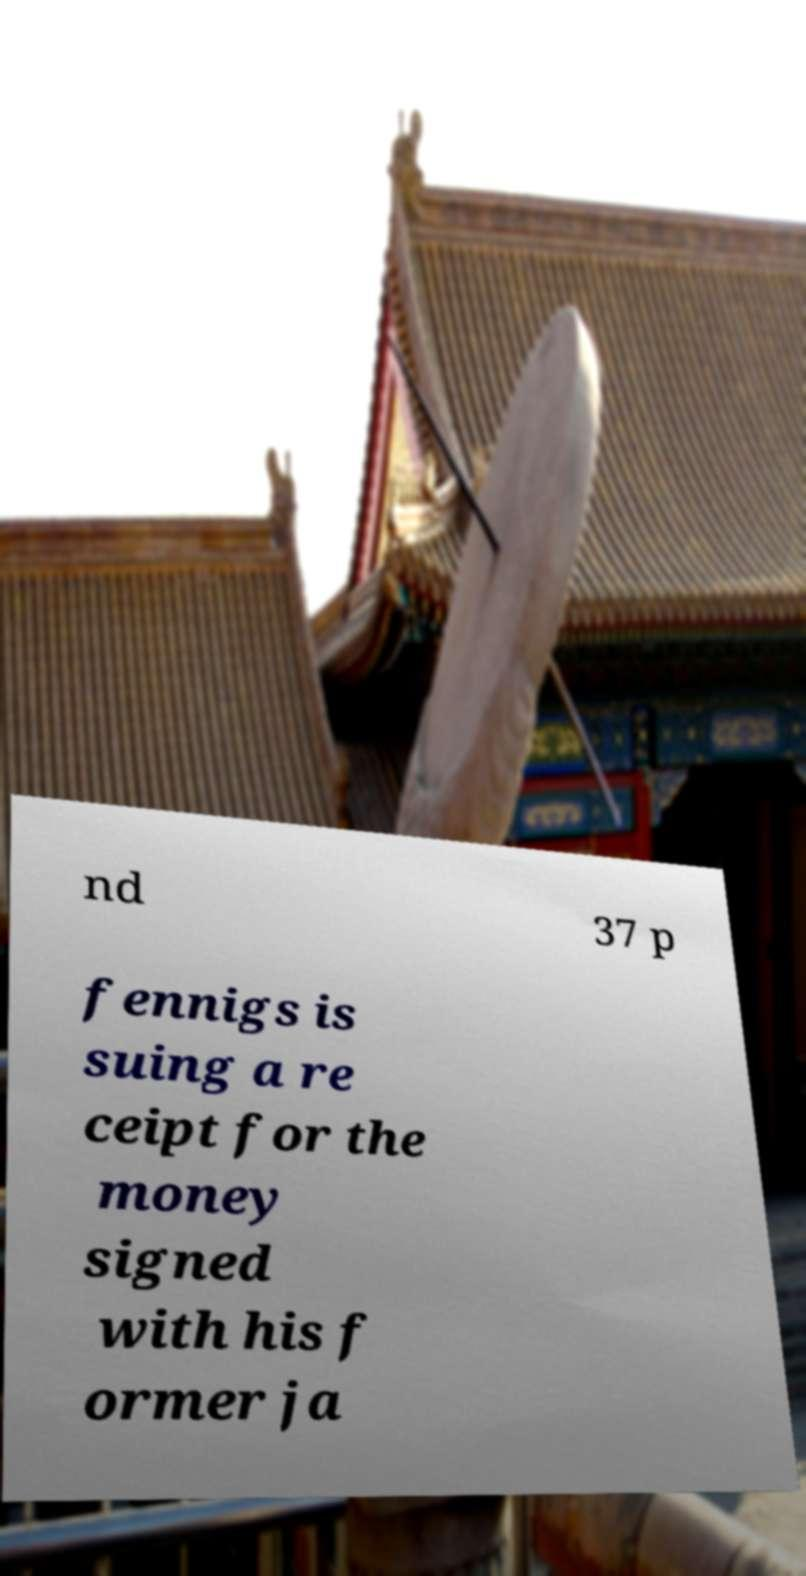What messages or text are displayed in this image? I need them in a readable, typed format. nd 37 p fennigs is suing a re ceipt for the money signed with his f ormer ja 